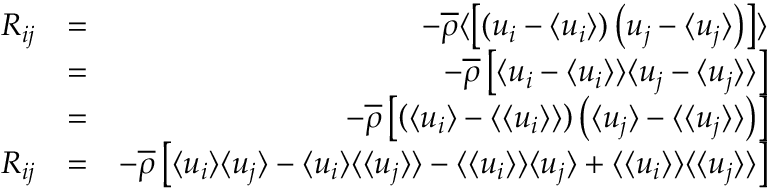<formula> <loc_0><loc_0><loc_500><loc_500>\begin{array} { r l r } { R _ { i j } } & { = } & { - \overline { \rho } \langle \left [ \left ( u _ { i } - \langle u _ { i } \rangle \right ) \left ( u _ { j } - \langle u _ { j } \rangle \right ) \right ] \rangle } \\ & { = } & { - \overline { \rho } \left [ \langle u _ { i } - \langle u _ { i } \rangle \rangle \langle u _ { j } - \langle u _ { j } \rangle \rangle \right ] } \\ & { = } & { - \overline { \rho } \left [ \left ( \langle u _ { i } \rangle - \langle \langle u _ { i } \rangle \rangle \right ) \left ( \langle u _ { j } \rangle - \langle \langle u _ { j } \rangle \rangle \right ) \right ] } \\ { R _ { i j } } & { = } & { - \overline { \rho } \left [ \langle u _ { i } \rangle \langle u _ { j } \rangle - \langle u _ { i } \rangle \langle \langle u _ { j } \rangle \rangle - \langle \langle u _ { i } \rangle \rangle \langle u _ { j } \rangle + \langle \langle u _ { i } \rangle \rangle \langle \langle u _ { j } \rangle \rangle \right ] } \end{array}</formula> 